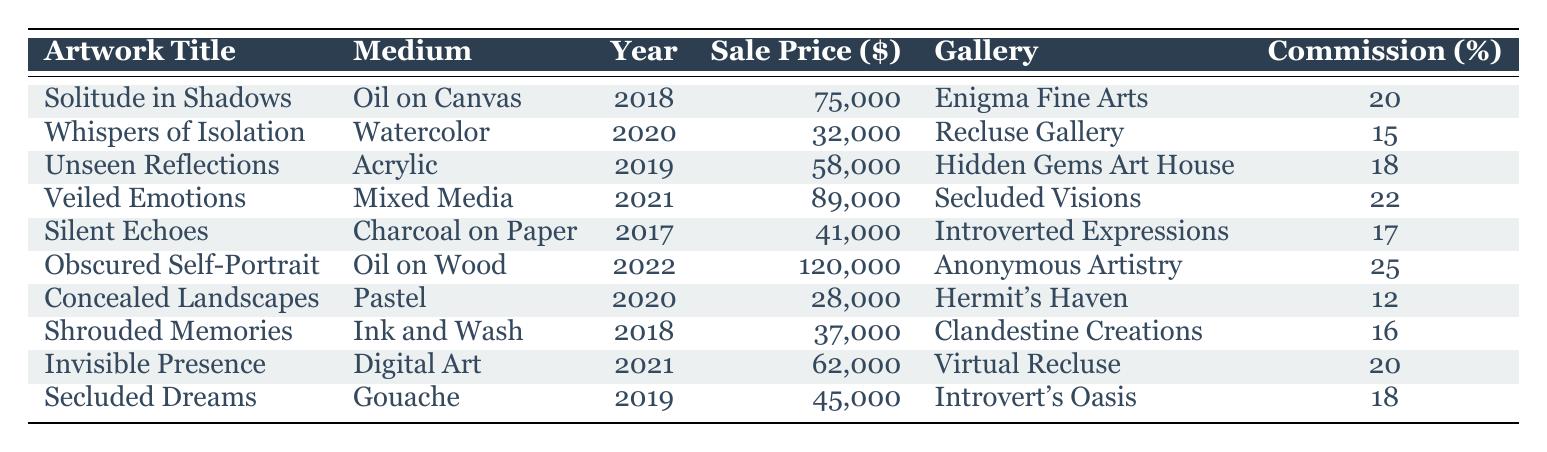What is the sale price of "Obscured Self-Portrait"? The sale price of "Obscured Self-Portrait" is listed in the table as 120,000 dollars.
Answer: 120000 Which artwork has the highest commission percentage? The artwork with the highest commission percentage is "Obscured Self-Portrait", with a commission of 25%.
Answer: 25 What is the average sale price of artworks sold in 2020? The artworks sold in 2020 are "Whispers of Isolation" at 32,000 and "Concealed Landscapes" at 28,000. The total sale price is 32,000 + 28,000 = 60,000. Dividing by 2 gives an average of 60,000 / 2 = 30,000.
Answer: 30000 Did any artwork sell for less than 35,000 dollars? Yes, there are artworks that sold for less than 35,000 dollars, specifically "Whispers of Isolation" at 32,000 and "Concealed Landscapes" at 28,000.
Answer: Yes How many artworks were created in 2019? The artworks created in 2019 are "Unseen Reflections" and "Secluded Dreams". There are 2 artworks listed for that year.
Answer: 2 What is the total commission earned from the sales of all artworks? To find the total commission, we first calculate the commission for each artwork: 20% of 75,000 is 15,000; 15% of 32,000 is 4,800; 18% of 58,000 is 10,440; 22% of 89,000 is 19,580; 17% of 41,000 is 6,970; 25% of 120,000 is 30,000; 12% of 28,000 is 3,360; 16% of 37,000 is 5,920; 20% of 62,000 is 12,400; 18% of 45,000 is 8,100. Adding these gives a total commission of 15,000 + 4,800 + 10,440 + 19,580 + 6,970 + 30,000 + 3,360 + 5,920 + 12,400 + 8,100 = 116,170.
Answer: 116170 Which medium has the most artworks represented in the sales? By counting the mediums, we have Oil on Canvas (1), Watercolor (1), Acrylic (1), Mixed Media (1), Charcoal on Paper (1), Oil on Wood (1), Pastel (1), Ink and Wash (1), Digital Art (1), and Gouache (1). Each medium is represented only once; therefore, all have an equal representation of 1.
Answer: Equal representation What is the difference in sale price between the highest and lowest selling artwork? The highest selling artwork is "Obscured Self-Portrait" at 120,000 dollars, and the lowest selling artwork is "Concealed Landscapes" at 28,000 dollars. The difference is calculated as 120,000 - 28,000 = 92,000 dollars.
Answer: 92000 